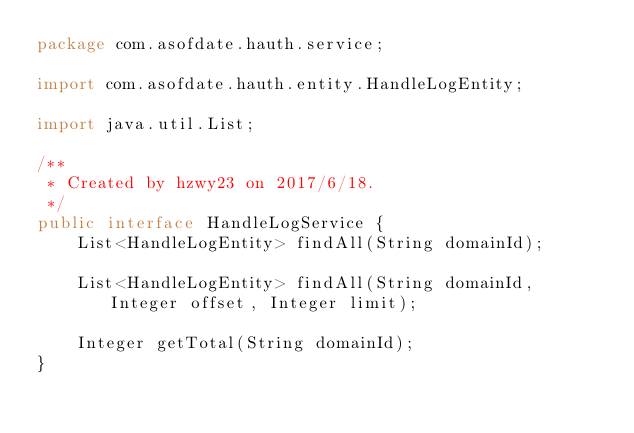<code> <loc_0><loc_0><loc_500><loc_500><_Java_>package com.asofdate.hauth.service;

import com.asofdate.hauth.entity.HandleLogEntity;

import java.util.List;

/**
 * Created by hzwy23 on 2017/6/18.
 */
public interface HandleLogService {
    List<HandleLogEntity> findAll(String domainId);

    List<HandleLogEntity> findAll(String domainId, Integer offset, Integer limit);

    Integer getTotal(String domainId);
}
</code> 